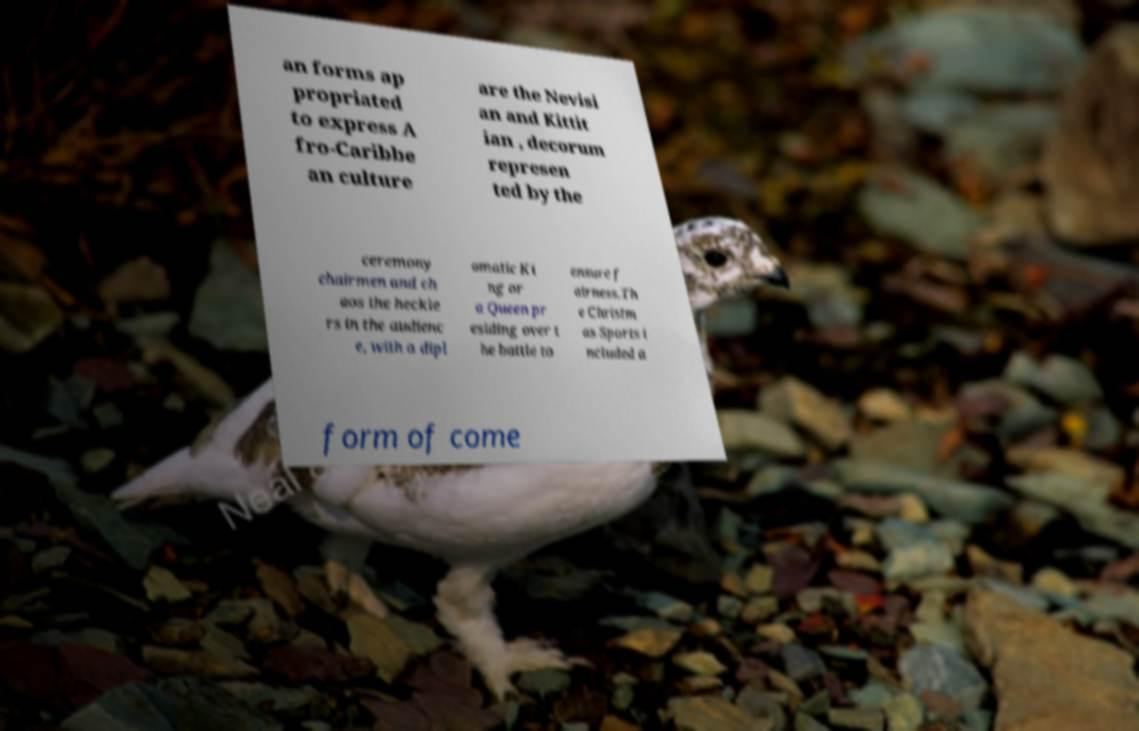Could you assist in decoding the text presented in this image and type it out clearly? an forms ap propriated to express A fro-Caribbe an culture are the Nevisi an and Kittit ian , decorum represen ted by the ceremony chairmen and ch aos the heckle rs in the audienc e, with a dipl omatic Ki ng or a Queen pr esiding over t he battle to ensure f airness.Th e Christm as Sports i ncluded a form of come 